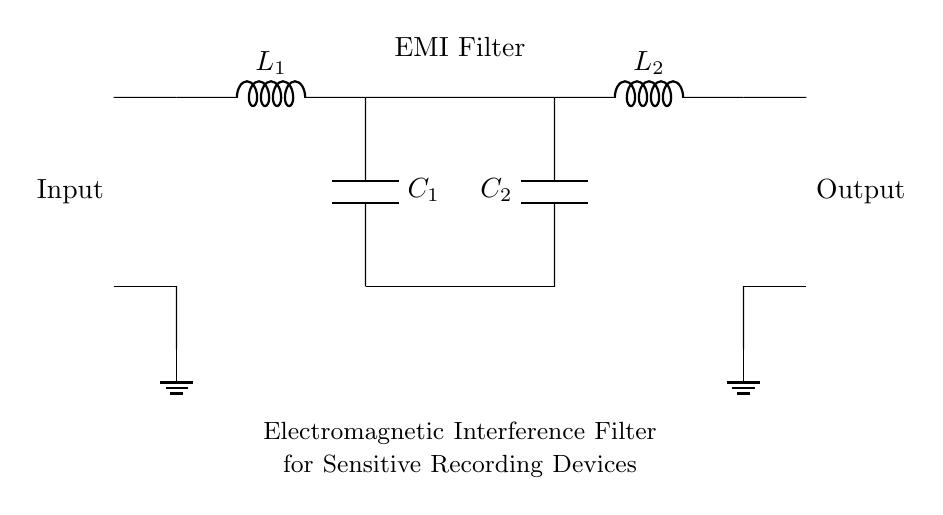What components are included in the EMI filter? The components are two inductors (L1, L2) and two capacitors (C1, C2). These components are shown connected in a way that they form an EMI filter.
Answer: two inductors and two capacitors What type of filter is represented in this circuit? This circuit represents an Electromagnetic Interference (EMI) filter, which is designed to suppress unwanted electromagnetic signals. The label in the circuit diagram states its purpose clearly.
Answer: Electromagnetic Interference filter How many components are connected in series in the EMI filter section? There are two inductors (L1, L2) and two capacitors (C1, C2) in the EMI filter section. The circuit diagram shows L1 and C1 in series, followed by L2. Thus, there are three series connections in total.
Answer: three What is the function of the inductors (L1, L2) in the EMI filter? The inductors are used to block high-frequency signals while allowing low-frequency signals to pass through. This behavior helps in reducing electromagnetic interference.
Answer: to block high-frequency signals What happens to the signal as it passes through the capacitors (C1, C2)? The capacitors are placed to shunt higher-frequency noise to the ground, preventing it from reaching the output. This means they allow AC signals to pass while blocking DC.
Answer: shunt higher-frequency noise to ground What can be inferred about the filter design based on the placement of components? The combination of inductors and capacitors indicates a low-pass filter design, which is typical in EMI filters for sensitive recording devices. This combination suggests an aim to filter out high-frequency noise while allowing low frequencies to be transmitted.
Answer: low-pass filter design 